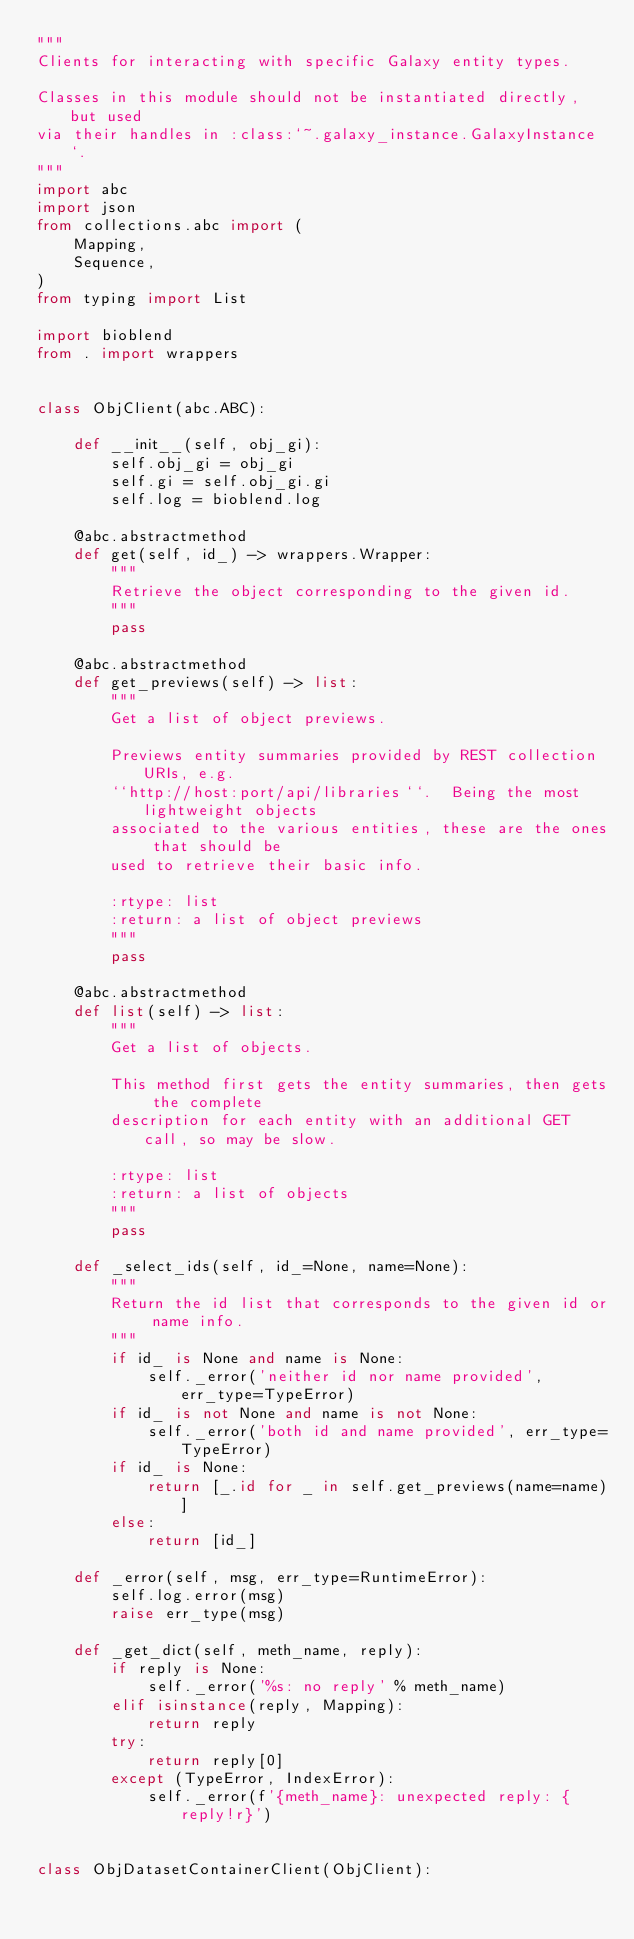<code> <loc_0><loc_0><loc_500><loc_500><_Python_>"""
Clients for interacting with specific Galaxy entity types.

Classes in this module should not be instantiated directly, but used
via their handles in :class:`~.galaxy_instance.GalaxyInstance`.
"""
import abc
import json
from collections.abc import (
    Mapping,
    Sequence,
)
from typing import List

import bioblend
from . import wrappers


class ObjClient(abc.ABC):

    def __init__(self, obj_gi):
        self.obj_gi = obj_gi
        self.gi = self.obj_gi.gi
        self.log = bioblend.log

    @abc.abstractmethod
    def get(self, id_) -> wrappers.Wrapper:
        """
        Retrieve the object corresponding to the given id.
        """
        pass

    @abc.abstractmethod
    def get_previews(self) -> list:
        """
        Get a list of object previews.

        Previews entity summaries provided by REST collection URIs, e.g.
        ``http://host:port/api/libraries``.  Being the most lightweight objects
        associated to the various entities, these are the ones that should be
        used to retrieve their basic info.

        :rtype: list
        :return: a list of object previews
        """
        pass

    @abc.abstractmethod
    def list(self) -> list:
        """
        Get a list of objects.

        This method first gets the entity summaries, then gets the complete
        description for each entity with an additional GET call, so may be slow.

        :rtype: list
        :return: a list of objects
        """
        pass

    def _select_ids(self, id_=None, name=None):
        """
        Return the id list that corresponds to the given id or name info.
        """
        if id_ is None and name is None:
            self._error('neither id nor name provided', err_type=TypeError)
        if id_ is not None and name is not None:
            self._error('both id and name provided', err_type=TypeError)
        if id_ is None:
            return [_.id for _ in self.get_previews(name=name)]
        else:
            return [id_]

    def _error(self, msg, err_type=RuntimeError):
        self.log.error(msg)
        raise err_type(msg)

    def _get_dict(self, meth_name, reply):
        if reply is None:
            self._error('%s: no reply' % meth_name)
        elif isinstance(reply, Mapping):
            return reply
        try:
            return reply[0]
        except (TypeError, IndexError):
            self._error(f'{meth_name}: unexpected reply: {reply!r}')


class ObjDatasetContainerClient(ObjClient):
</code> 